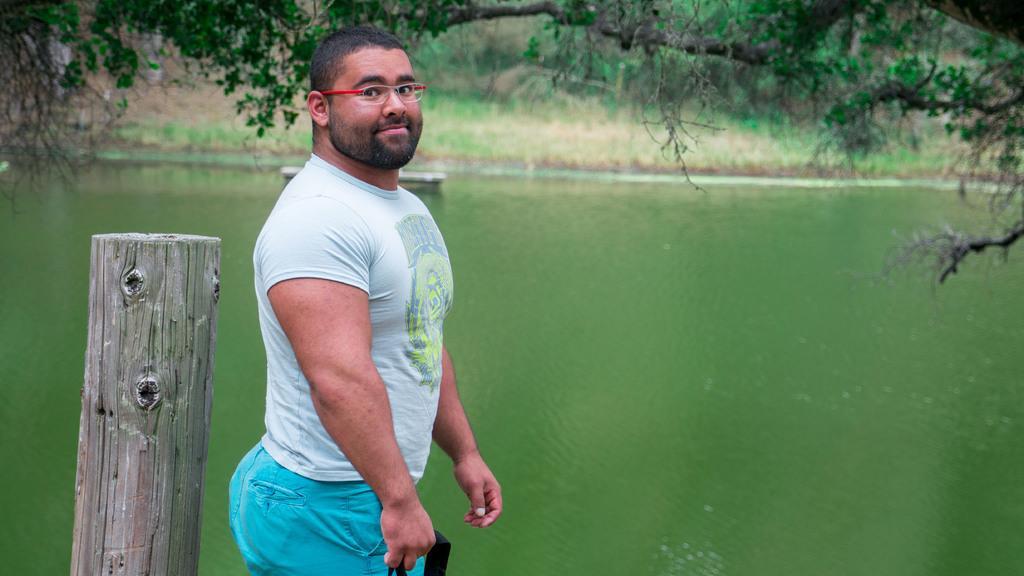Describe this image in one or two sentences. In this image I can see a person wearing t shirt and blue pant is standing and I can see a wooden log behind him. In the background I can see the water, some grass and few trees. 